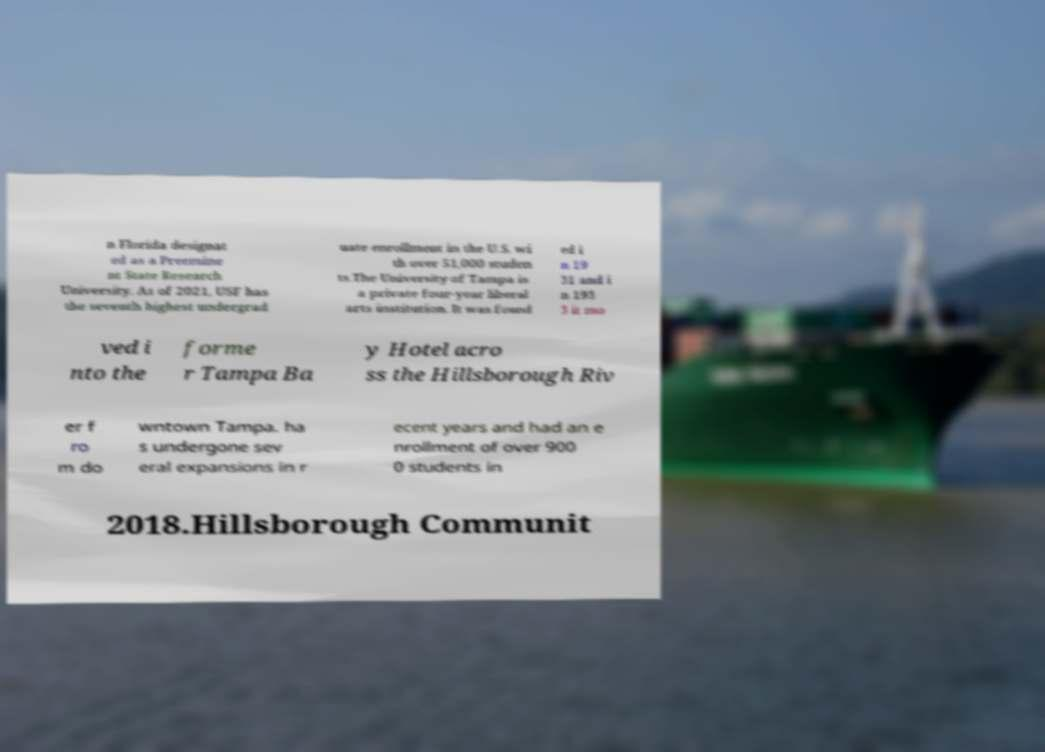There's text embedded in this image that I need extracted. Can you transcribe it verbatim? n Florida designat ed as a Preemine nt State Research University. As of 2021, USF has the seventh highest undergrad uate enrollment in the U.S. wi th over 51,000 studen ts.The University of Tampa is a private four-year liberal arts institution. It was found ed i n 19 31 and i n 193 3 it mo ved i nto the forme r Tampa Ba y Hotel acro ss the Hillsborough Riv er f ro m do wntown Tampa. ha s undergone sev eral expansions in r ecent years and had an e nrollment of over 900 0 students in 2018.Hillsborough Communit 